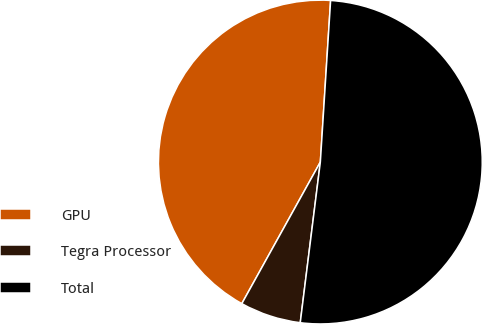Convert chart to OTSL. <chart><loc_0><loc_0><loc_500><loc_500><pie_chart><fcel>GPU<fcel>Tegra Processor<fcel>Total<nl><fcel>42.95%<fcel>6.08%<fcel>50.97%<nl></chart> 